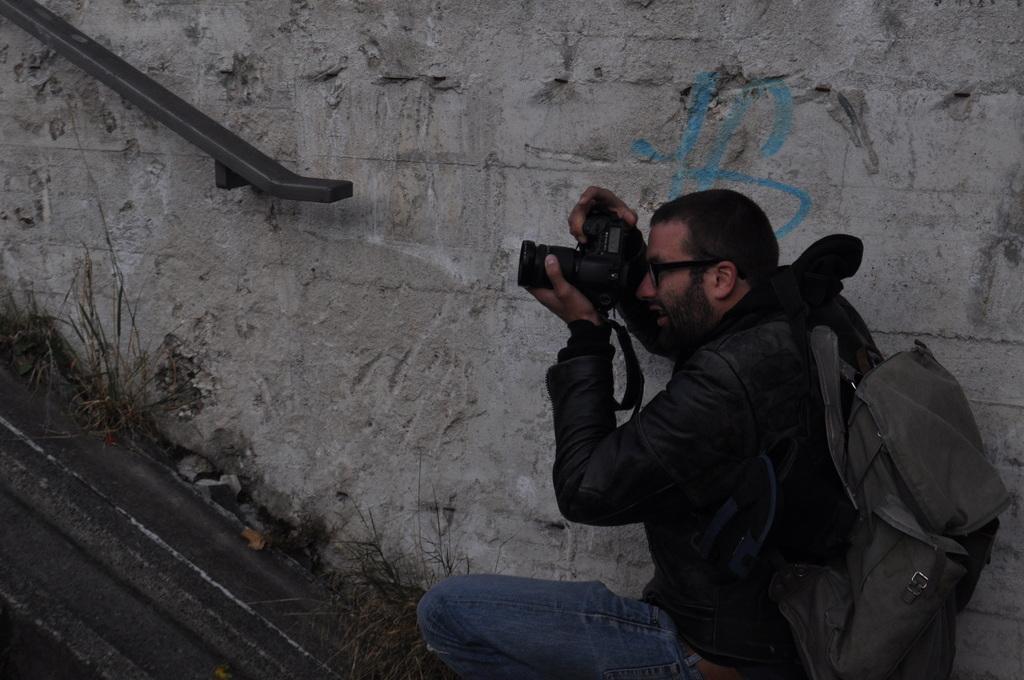Can you describe this image briefly? In the given image we can see a man catching a camera in his hand. He is wearing a bag and black color jacket. This is a grass. 